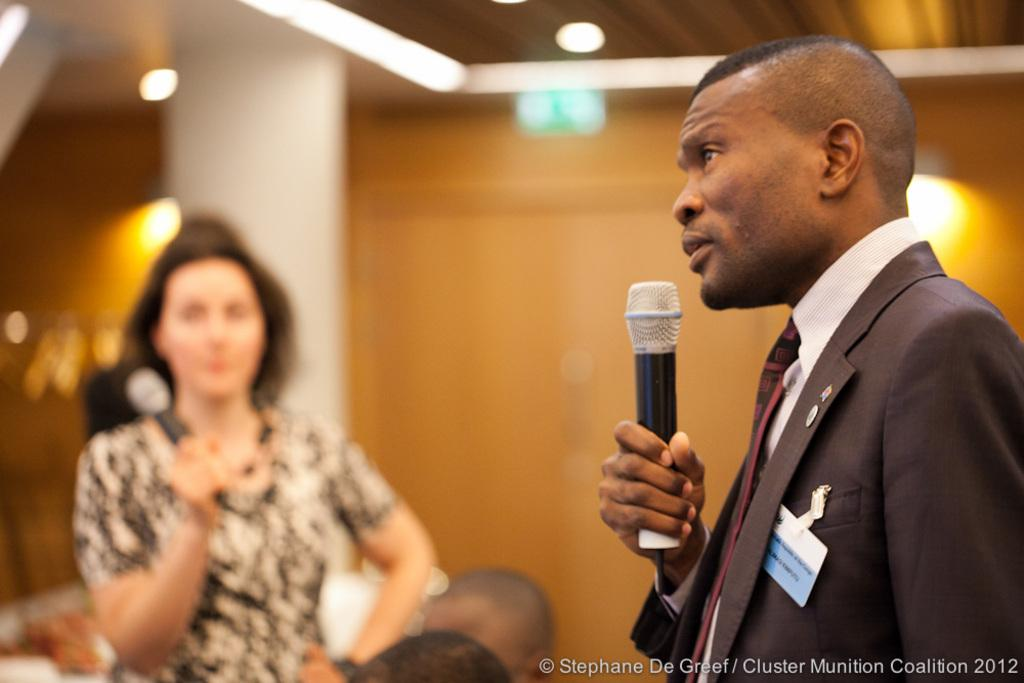How many people are in the image? There are two persons standing in the image. What are the persons holding in their hands? The persons are holding microphones. What can be seen in the background of the image? There is a wall and a pillar in the background of the image. What is visible at the top of the image? There are lights visible at the top of the image. What type of shock can be seen coming from the microphones in the image? There is no shock visible coming from the microphones in the image. Are there any flames present in the image? No, there are no flames present in the image. 